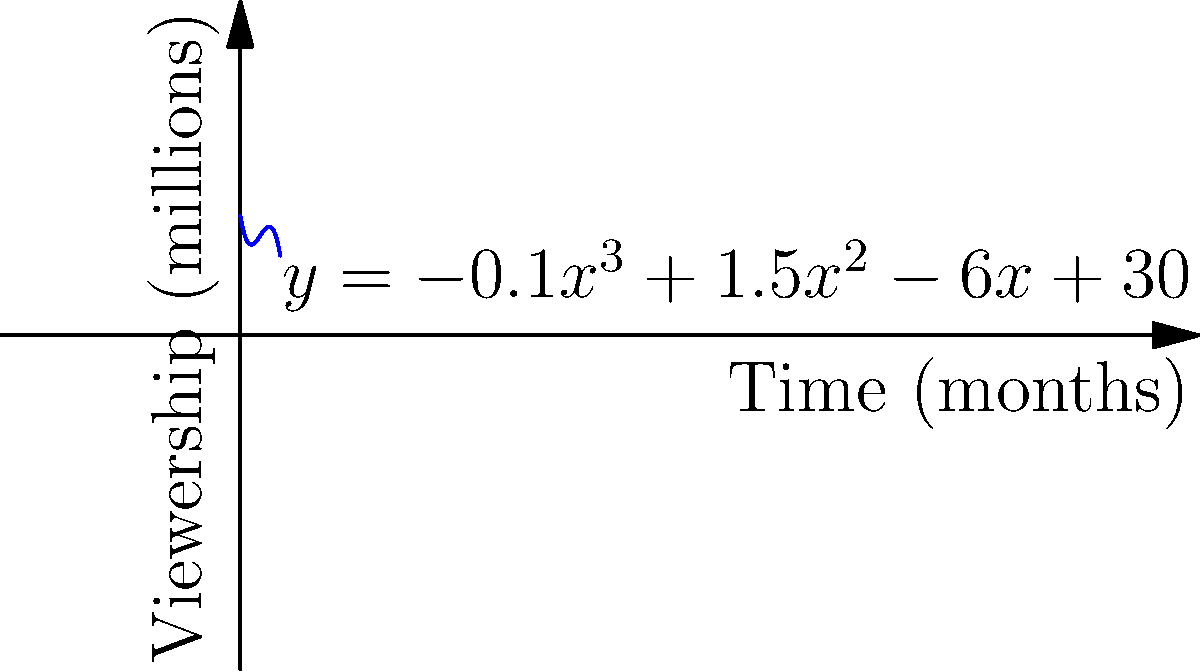As a conservative news reporter in Richmond, you're analyzing the viewership trends of your network's flagship program. The polynomial function $f(x)=-0.1x^3+1.5x^2-6x+30$ represents the viewership in millions over time, where $x$ is the number of months since the program's launch. At what month does the program reach its peak viewership? To find the month of peak viewership, we need to determine the maximum point of the function. This occurs where the derivative of the function equals zero.

1. Find the derivative of $f(x)$:
   $f'(x) = -0.3x^2 + 3x - 6$

2. Set the derivative equal to zero and solve:
   $-0.3x^2 + 3x - 6 = 0$

3. This is a quadratic equation. We can solve it using the quadratic formula:
   $x = \frac{-b \pm \sqrt{b^2 - 4ac}}{2a}$

   Where $a=-0.3$, $b=3$, and $c=-6$

4. Plugging in these values:
   $x = \frac{-3 \pm \sqrt{3^2 - 4(-0.3)(-6)}}{2(-0.3)}$

5. Simplifying:
   $x = \frac{-3 \pm \sqrt{9 - 7.2}}{-0.6} = \frac{-3 \pm \sqrt{1.8}}{-0.6}$

6. Calculating:
   $x \approx 5$ or $x \approx 5$

The solution $x \approx 5$ represents the maximum point (peak viewership) as it's the smaller value, which corresponds to the peak before the decline.

Therefore, the program reaches its peak viewership at approximately 5 months after launch.
Answer: 5 months 